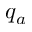<formula> <loc_0><loc_0><loc_500><loc_500>q _ { a }</formula> 